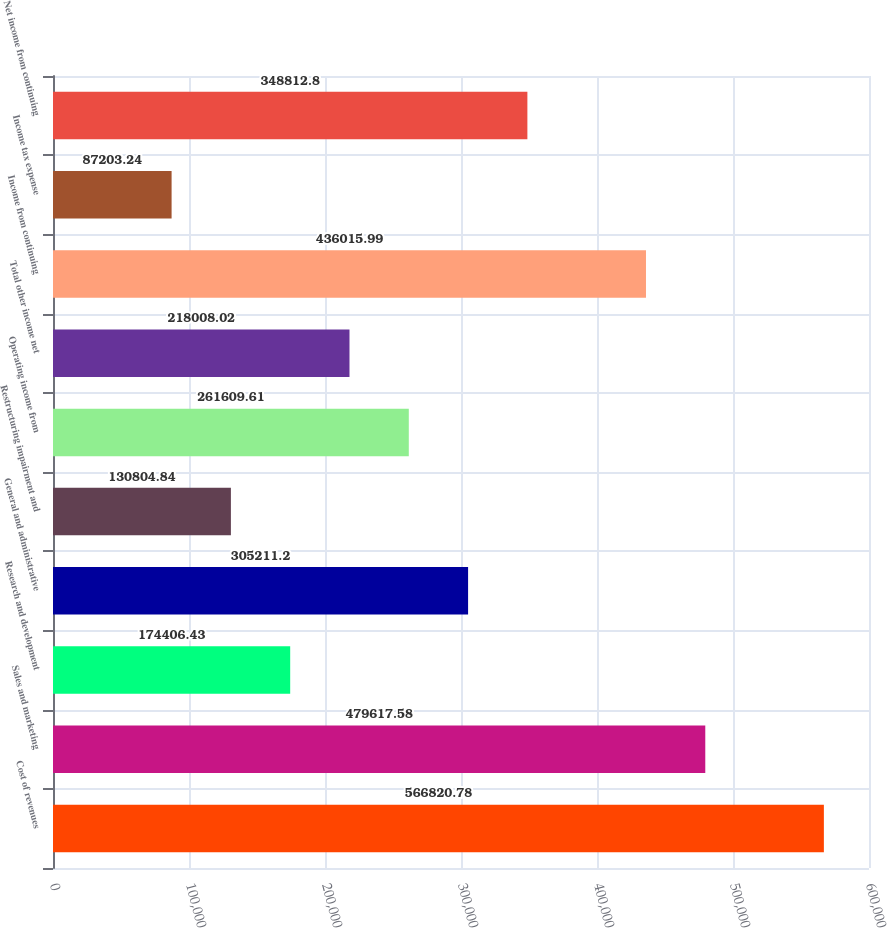Convert chart to OTSL. <chart><loc_0><loc_0><loc_500><loc_500><bar_chart><fcel>Cost of revenues<fcel>Sales and marketing<fcel>Research and development<fcel>General and administrative<fcel>Restructuring impairment and<fcel>Operating income from<fcel>Total other income net<fcel>Income from continuing<fcel>Income tax expense<fcel>Net income from continuing<nl><fcel>566821<fcel>479618<fcel>174406<fcel>305211<fcel>130805<fcel>261610<fcel>218008<fcel>436016<fcel>87203.2<fcel>348813<nl></chart> 